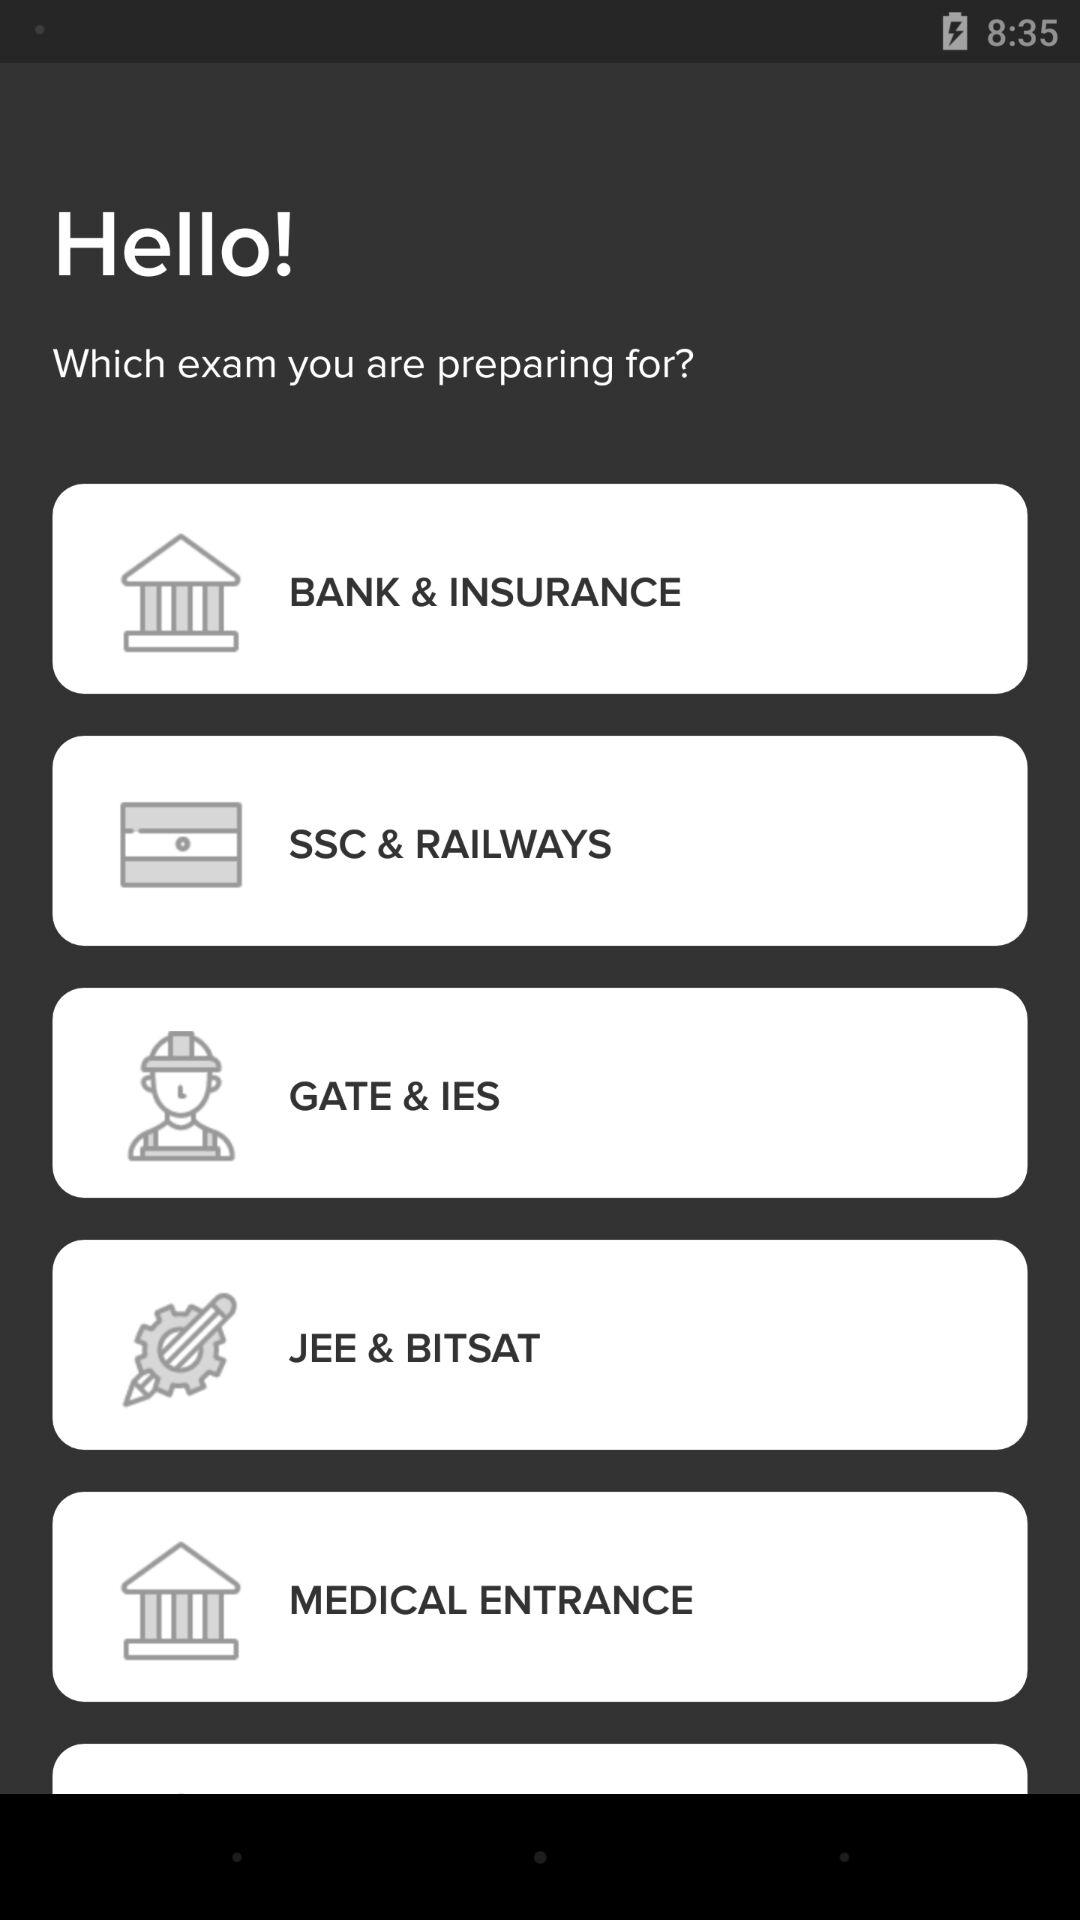How many questions are in the "BANK & INSURANCE" exam?
When the provided information is insufficient, respond with <no answer>. <no answer> 